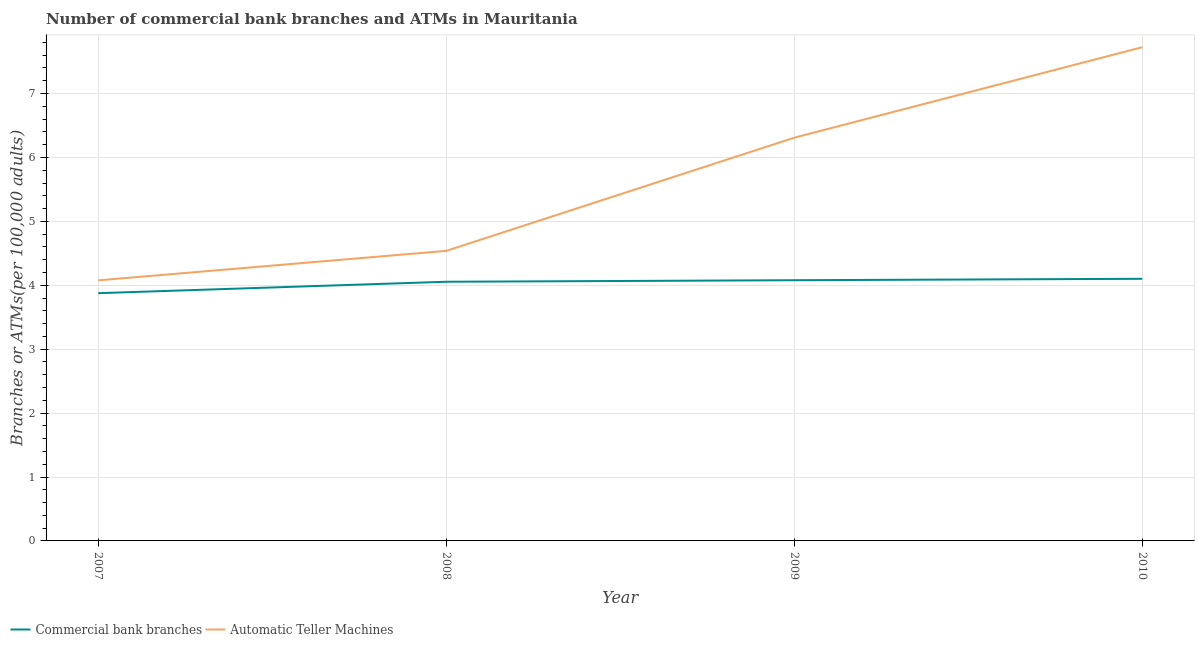What is the number of atms in 2009?
Offer a very short reply. 6.31. Across all years, what is the maximum number of commercal bank branches?
Make the answer very short. 4.1. Across all years, what is the minimum number of atms?
Offer a very short reply. 4.08. In which year was the number of atms maximum?
Give a very brief answer. 2010. What is the total number of atms in the graph?
Give a very brief answer. 22.65. What is the difference between the number of commercal bank branches in 2008 and that in 2009?
Give a very brief answer. -0.02. What is the difference between the number of atms in 2008 and the number of commercal bank branches in 2007?
Offer a very short reply. 0.66. What is the average number of commercal bank branches per year?
Offer a terse response. 4.03. In the year 2009, what is the difference between the number of commercal bank branches and number of atms?
Provide a succinct answer. -2.23. What is the ratio of the number of commercal bank branches in 2008 to that in 2010?
Offer a terse response. 0.99. Is the difference between the number of commercal bank branches in 2007 and 2010 greater than the difference between the number of atms in 2007 and 2010?
Your answer should be compact. Yes. What is the difference between the highest and the second highest number of atms?
Provide a short and direct response. 1.42. What is the difference between the highest and the lowest number of atms?
Offer a very short reply. 3.65. In how many years, is the number of commercal bank branches greater than the average number of commercal bank branches taken over all years?
Give a very brief answer. 3. Is the sum of the number of atms in 2007 and 2008 greater than the maximum number of commercal bank branches across all years?
Your response must be concise. Yes. Is the number of atms strictly greater than the number of commercal bank branches over the years?
Keep it short and to the point. Yes. How many years are there in the graph?
Your answer should be very brief. 4. What is the difference between two consecutive major ticks on the Y-axis?
Keep it short and to the point. 1. Does the graph contain grids?
Keep it short and to the point. Yes. Where does the legend appear in the graph?
Keep it short and to the point. Bottom left. How many legend labels are there?
Keep it short and to the point. 2. How are the legend labels stacked?
Keep it short and to the point. Horizontal. What is the title of the graph?
Your answer should be compact. Number of commercial bank branches and ATMs in Mauritania. What is the label or title of the Y-axis?
Your response must be concise. Branches or ATMs(per 100,0 adults). What is the Branches or ATMs(per 100,000 adults) in Commercial bank branches in 2007?
Provide a short and direct response. 3.88. What is the Branches or ATMs(per 100,000 adults) in Automatic Teller Machines in 2007?
Your answer should be very brief. 4.08. What is the Branches or ATMs(per 100,000 adults) in Commercial bank branches in 2008?
Give a very brief answer. 4.06. What is the Branches or ATMs(per 100,000 adults) of Automatic Teller Machines in 2008?
Your answer should be very brief. 4.54. What is the Branches or ATMs(per 100,000 adults) in Commercial bank branches in 2009?
Your response must be concise. 4.08. What is the Branches or ATMs(per 100,000 adults) in Automatic Teller Machines in 2009?
Offer a very short reply. 6.31. What is the Branches or ATMs(per 100,000 adults) in Commercial bank branches in 2010?
Offer a very short reply. 4.1. What is the Branches or ATMs(per 100,000 adults) of Automatic Teller Machines in 2010?
Your answer should be compact. 7.73. Across all years, what is the maximum Branches or ATMs(per 100,000 adults) in Commercial bank branches?
Make the answer very short. 4.1. Across all years, what is the maximum Branches or ATMs(per 100,000 adults) in Automatic Teller Machines?
Offer a terse response. 7.73. Across all years, what is the minimum Branches or ATMs(per 100,000 adults) of Commercial bank branches?
Provide a succinct answer. 3.88. Across all years, what is the minimum Branches or ATMs(per 100,000 adults) in Automatic Teller Machines?
Provide a short and direct response. 4.08. What is the total Branches or ATMs(per 100,000 adults) of Commercial bank branches in the graph?
Make the answer very short. 16.11. What is the total Branches or ATMs(per 100,000 adults) in Automatic Teller Machines in the graph?
Keep it short and to the point. 22.65. What is the difference between the Branches or ATMs(per 100,000 adults) in Commercial bank branches in 2007 and that in 2008?
Give a very brief answer. -0.18. What is the difference between the Branches or ATMs(per 100,000 adults) in Automatic Teller Machines in 2007 and that in 2008?
Offer a terse response. -0.46. What is the difference between the Branches or ATMs(per 100,000 adults) in Commercial bank branches in 2007 and that in 2009?
Give a very brief answer. -0.2. What is the difference between the Branches or ATMs(per 100,000 adults) in Automatic Teller Machines in 2007 and that in 2009?
Your response must be concise. -2.23. What is the difference between the Branches or ATMs(per 100,000 adults) in Commercial bank branches in 2007 and that in 2010?
Ensure brevity in your answer.  -0.23. What is the difference between the Branches or ATMs(per 100,000 adults) of Automatic Teller Machines in 2007 and that in 2010?
Provide a succinct answer. -3.65. What is the difference between the Branches or ATMs(per 100,000 adults) in Commercial bank branches in 2008 and that in 2009?
Offer a terse response. -0.02. What is the difference between the Branches or ATMs(per 100,000 adults) of Automatic Teller Machines in 2008 and that in 2009?
Make the answer very short. -1.77. What is the difference between the Branches or ATMs(per 100,000 adults) in Commercial bank branches in 2008 and that in 2010?
Offer a terse response. -0.05. What is the difference between the Branches or ATMs(per 100,000 adults) of Automatic Teller Machines in 2008 and that in 2010?
Provide a succinct answer. -3.19. What is the difference between the Branches or ATMs(per 100,000 adults) in Commercial bank branches in 2009 and that in 2010?
Provide a succinct answer. -0.02. What is the difference between the Branches or ATMs(per 100,000 adults) of Automatic Teller Machines in 2009 and that in 2010?
Your answer should be compact. -1.42. What is the difference between the Branches or ATMs(per 100,000 adults) of Commercial bank branches in 2007 and the Branches or ATMs(per 100,000 adults) of Automatic Teller Machines in 2008?
Provide a short and direct response. -0.66. What is the difference between the Branches or ATMs(per 100,000 adults) of Commercial bank branches in 2007 and the Branches or ATMs(per 100,000 adults) of Automatic Teller Machines in 2009?
Your answer should be very brief. -2.43. What is the difference between the Branches or ATMs(per 100,000 adults) of Commercial bank branches in 2007 and the Branches or ATMs(per 100,000 adults) of Automatic Teller Machines in 2010?
Keep it short and to the point. -3.85. What is the difference between the Branches or ATMs(per 100,000 adults) in Commercial bank branches in 2008 and the Branches or ATMs(per 100,000 adults) in Automatic Teller Machines in 2009?
Provide a short and direct response. -2.25. What is the difference between the Branches or ATMs(per 100,000 adults) of Commercial bank branches in 2008 and the Branches or ATMs(per 100,000 adults) of Automatic Teller Machines in 2010?
Your response must be concise. -3.67. What is the difference between the Branches or ATMs(per 100,000 adults) in Commercial bank branches in 2009 and the Branches or ATMs(per 100,000 adults) in Automatic Teller Machines in 2010?
Give a very brief answer. -3.65. What is the average Branches or ATMs(per 100,000 adults) of Commercial bank branches per year?
Your answer should be compact. 4.03. What is the average Branches or ATMs(per 100,000 adults) of Automatic Teller Machines per year?
Offer a terse response. 5.66. In the year 2007, what is the difference between the Branches or ATMs(per 100,000 adults) of Commercial bank branches and Branches or ATMs(per 100,000 adults) of Automatic Teller Machines?
Ensure brevity in your answer.  -0.2. In the year 2008, what is the difference between the Branches or ATMs(per 100,000 adults) of Commercial bank branches and Branches or ATMs(per 100,000 adults) of Automatic Teller Machines?
Offer a very short reply. -0.48. In the year 2009, what is the difference between the Branches or ATMs(per 100,000 adults) of Commercial bank branches and Branches or ATMs(per 100,000 adults) of Automatic Teller Machines?
Give a very brief answer. -2.23. In the year 2010, what is the difference between the Branches or ATMs(per 100,000 adults) in Commercial bank branches and Branches or ATMs(per 100,000 adults) in Automatic Teller Machines?
Your answer should be compact. -3.62. What is the ratio of the Branches or ATMs(per 100,000 adults) in Commercial bank branches in 2007 to that in 2008?
Make the answer very short. 0.96. What is the ratio of the Branches or ATMs(per 100,000 adults) of Automatic Teller Machines in 2007 to that in 2008?
Offer a very short reply. 0.9. What is the ratio of the Branches or ATMs(per 100,000 adults) in Commercial bank branches in 2007 to that in 2009?
Provide a short and direct response. 0.95. What is the ratio of the Branches or ATMs(per 100,000 adults) in Automatic Teller Machines in 2007 to that in 2009?
Your response must be concise. 0.65. What is the ratio of the Branches or ATMs(per 100,000 adults) in Commercial bank branches in 2007 to that in 2010?
Give a very brief answer. 0.95. What is the ratio of the Branches or ATMs(per 100,000 adults) of Automatic Teller Machines in 2007 to that in 2010?
Provide a short and direct response. 0.53. What is the ratio of the Branches or ATMs(per 100,000 adults) in Automatic Teller Machines in 2008 to that in 2009?
Make the answer very short. 0.72. What is the ratio of the Branches or ATMs(per 100,000 adults) in Commercial bank branches in 2008 to that in 2010?
Give a very brief answer. 0.99. What is the ratio of the Branches or ATMs(per 100,000 adults) in Automatic Teller Machines in 2008 to that in 2010?
Keep it short and to the point. 0.59. What is the ratio of the Branches or ATMs(per 100,000 adults) in Automatic Teller Machines in 2009 to that in 2010?
Your answer should be very brief. 0.82. What is the difference between the highest and the second highest Branches or ATMs(per 100,000 adults) in Commercial bank branches?
Ensure brevity in your answer.  0.02. What is the difference between the highest and the second highest Branches or ATMs(per 100,000 adults) in Automatic Teller Machines?
Give a very brief answer. 1.42. What is the difference between the highest and the lowest Branches or ATMs(per 100,000 adults) of Commercial bank branches?
Give a very brief answer. 0.23. What is the difference between the highest and the lowest Branches or ATMs(per 100,000 adults) of Automatic Teller Machines?
Make the answer very short. 3.65. 